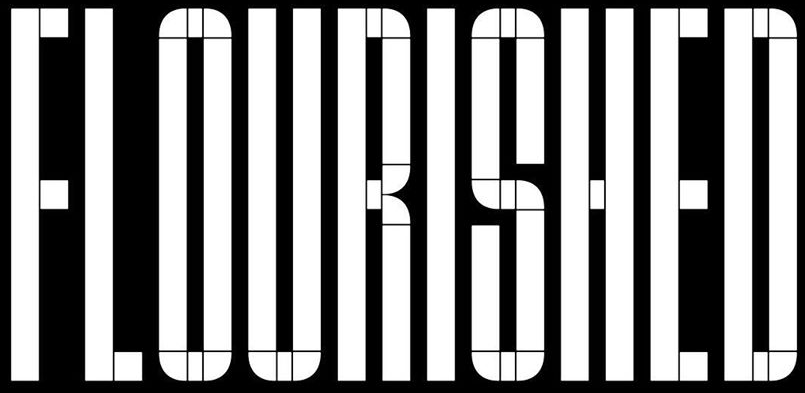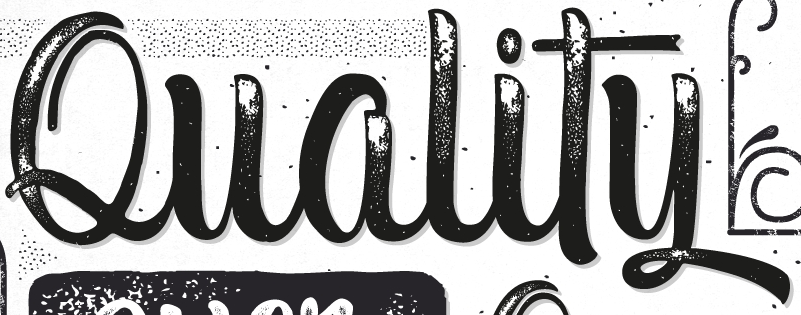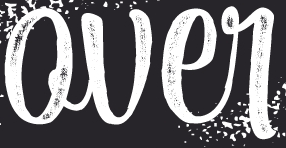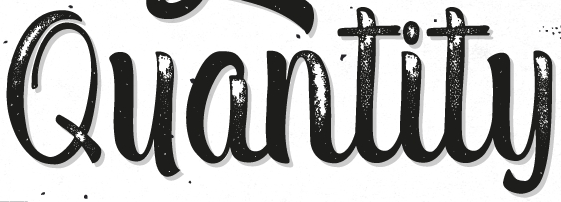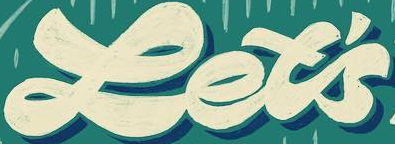What text is displayed in these images sequentially, separated by a semicolon? FLOURISHED; Quality; Qver; Quantity; Let's 